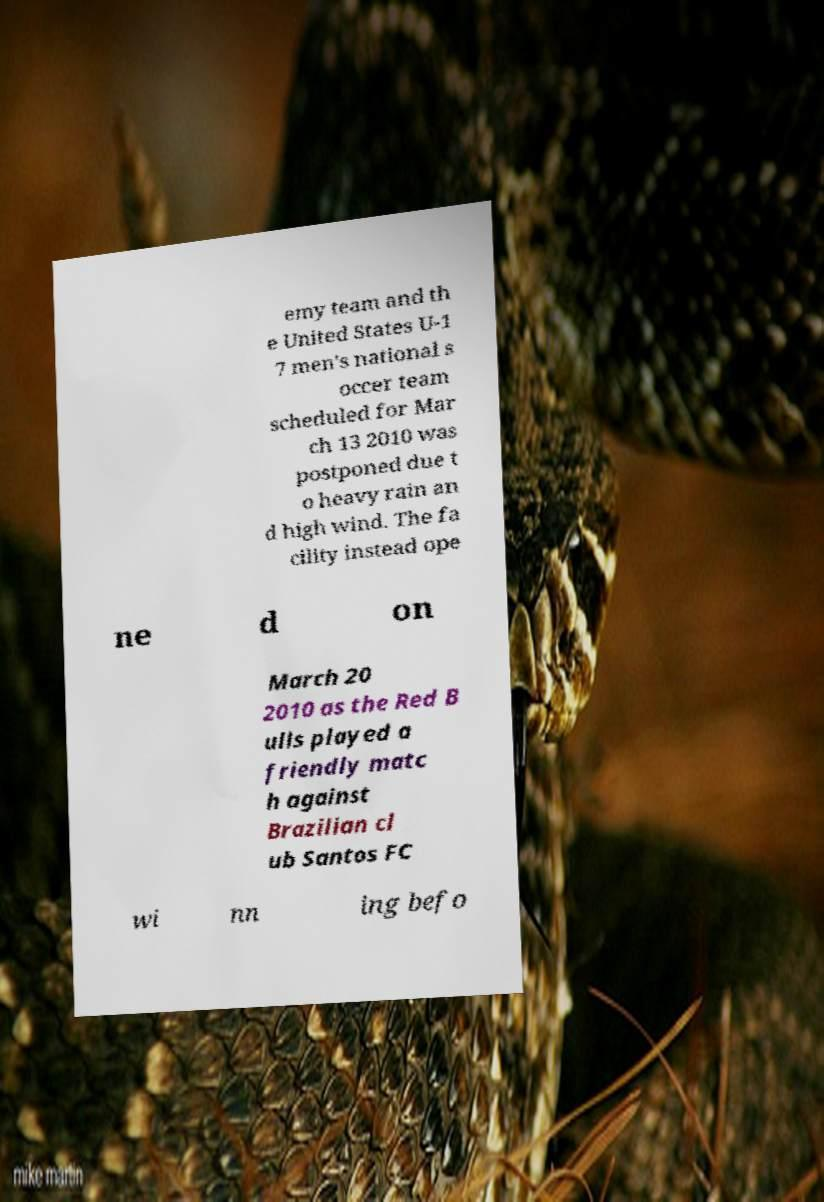I need the written content from this picture converted into text. Can you do that? emy team and th e United States U-1 7 men's national s occer team scheduled for Mar ch 13 2010 was postponed due t o heavy rain an d high wind. The fa cility instead ope ne d on March 20 2010 as the Red B ulls played a friendly matc h against Brazilian cl ub Santos FC wi nn ing befo 